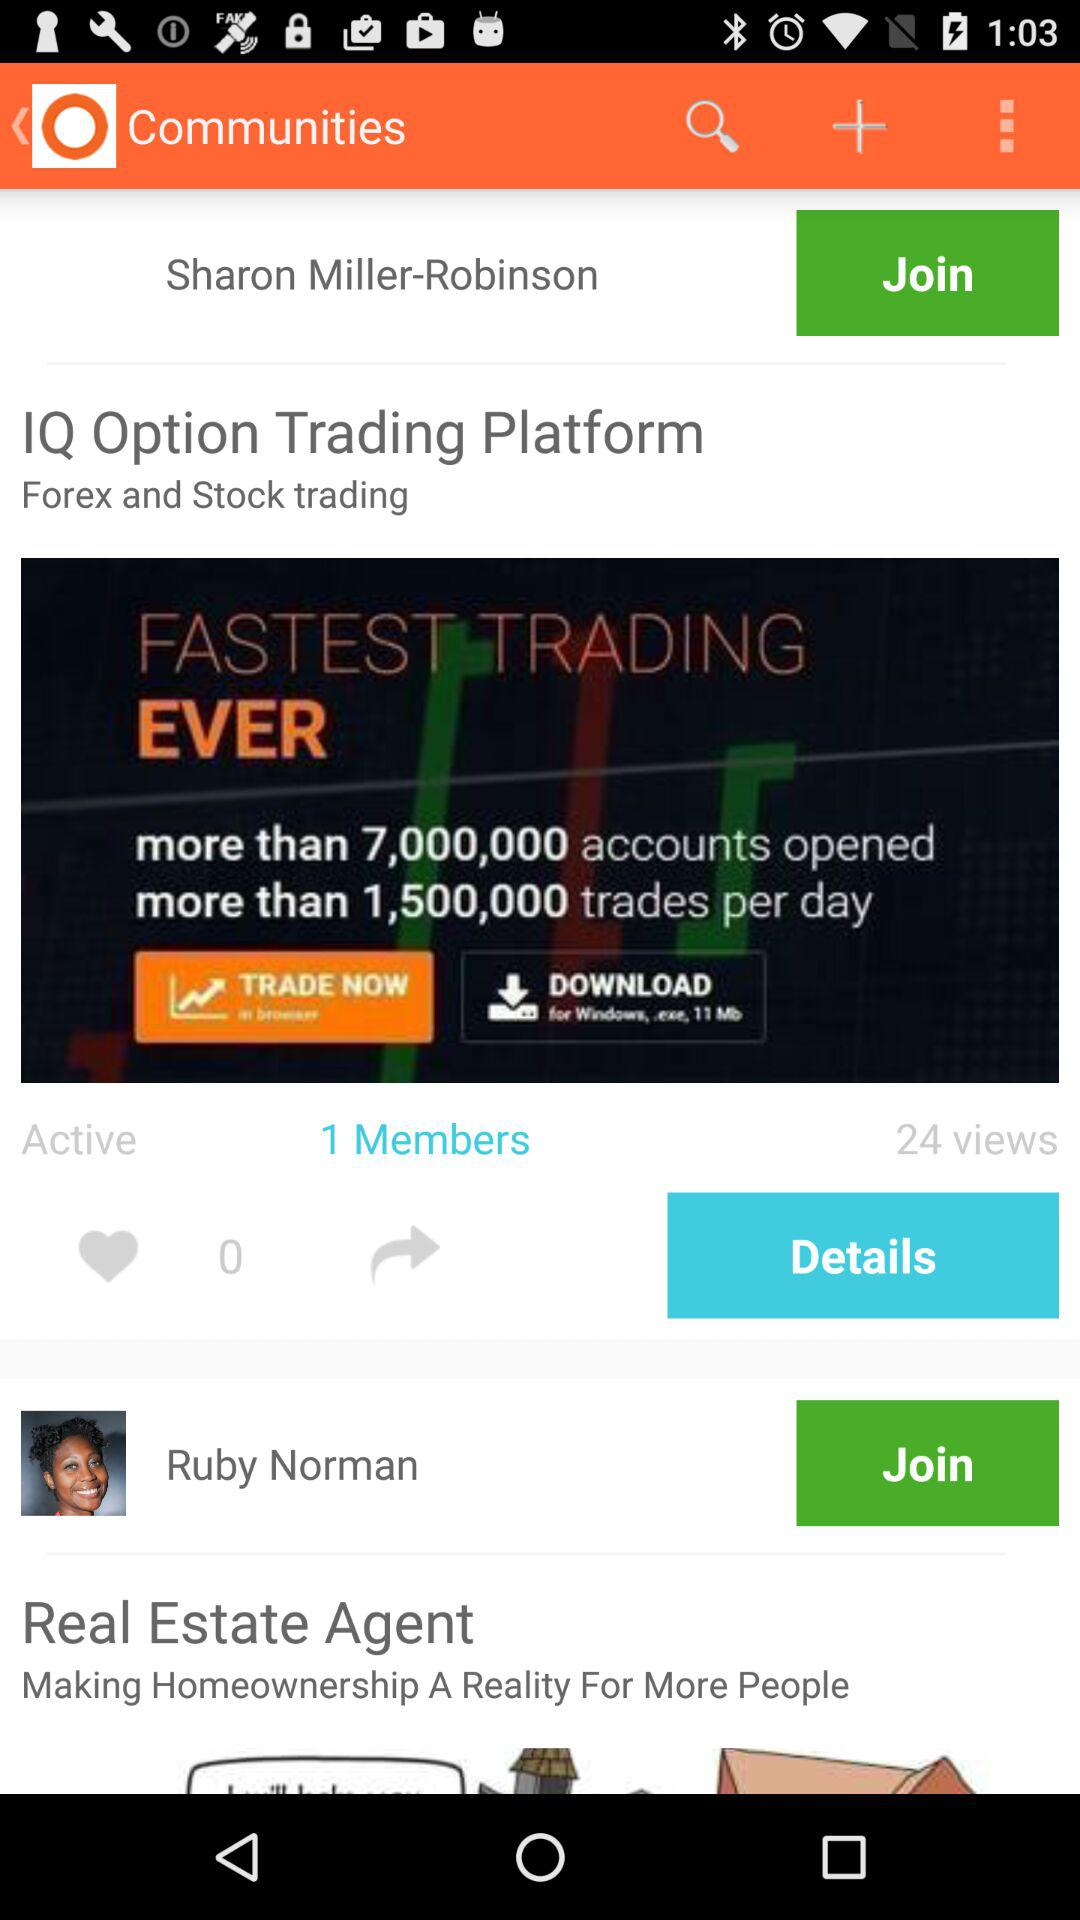What is the count of likes? The count of likes is 0. 